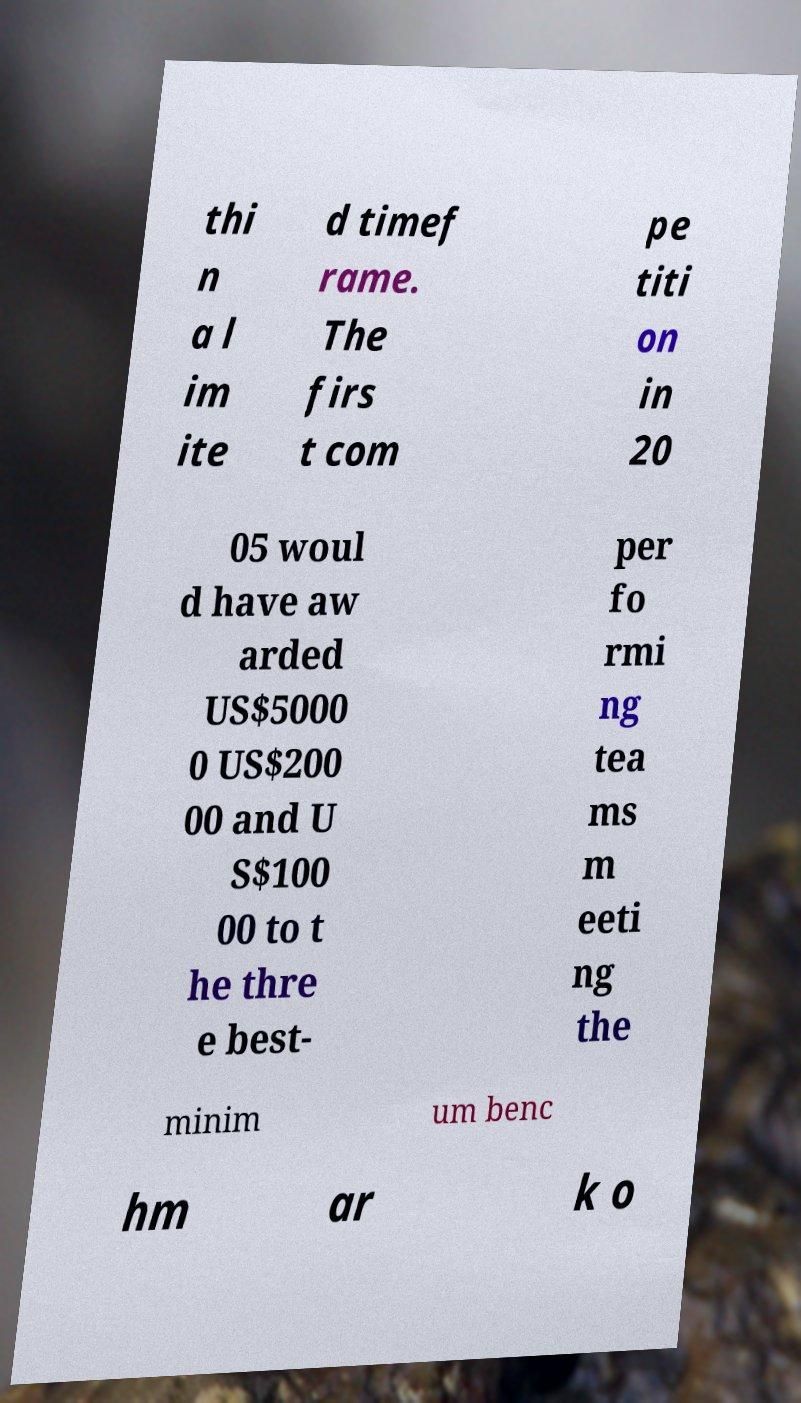Please identify and transcribe the text found in this image. thi n a l im ite d timef rame. The firs t com pe titi on in 20 05 woul d have aw arded US$5000 0 US$200 00 and U S$100 00 to t he thre e best- per fo rmi ng tea ms m eeti ng the minim um benc hm ar k o 